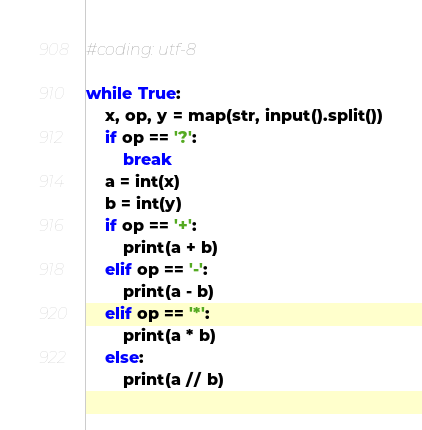Convert code to text. <code><loc_0><loc_0><loc_500><loc_500><_Python_>#coding: utf-8

while True:
    x, op, y = map(str, input().split())
    if op == '?':
        break
    a = int(x)
    b = int(y)
    if op == '+':
        print(a + b)
    elif op == '-':
        print(a - b)
    elif op == '*':
        print(a * b)
    else:
        print(a // b)
</code> 